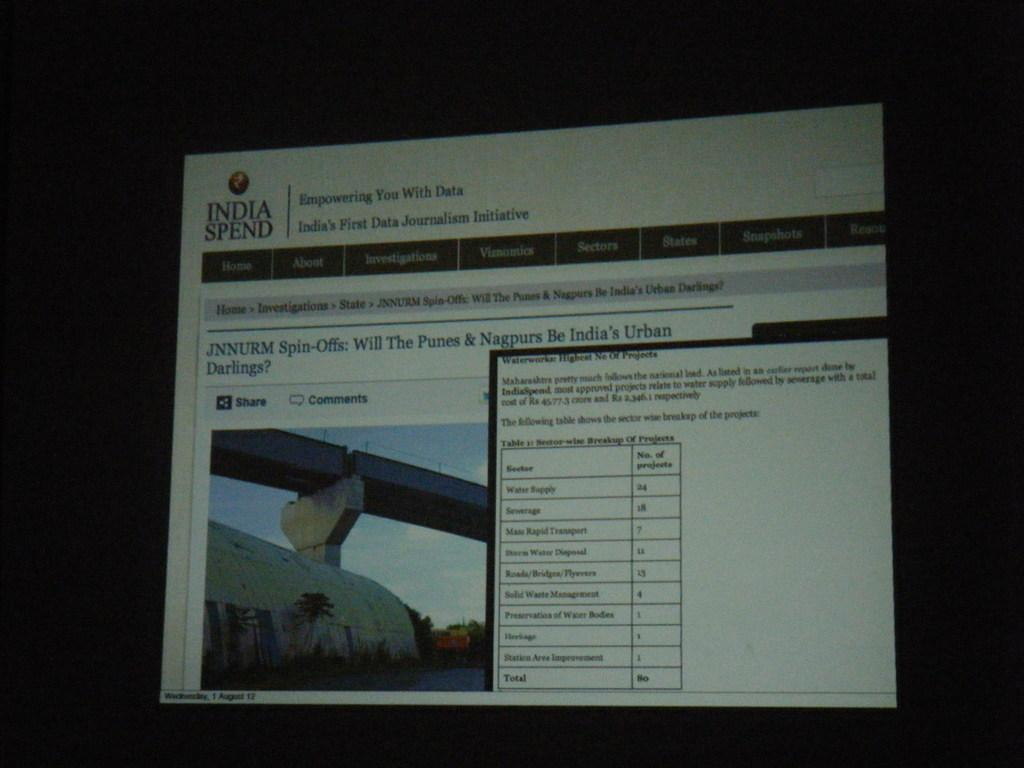<image>
Write a terse but informative summary of the picture. A computer monitor is open to a page with the words empowering you with Data at the top. 